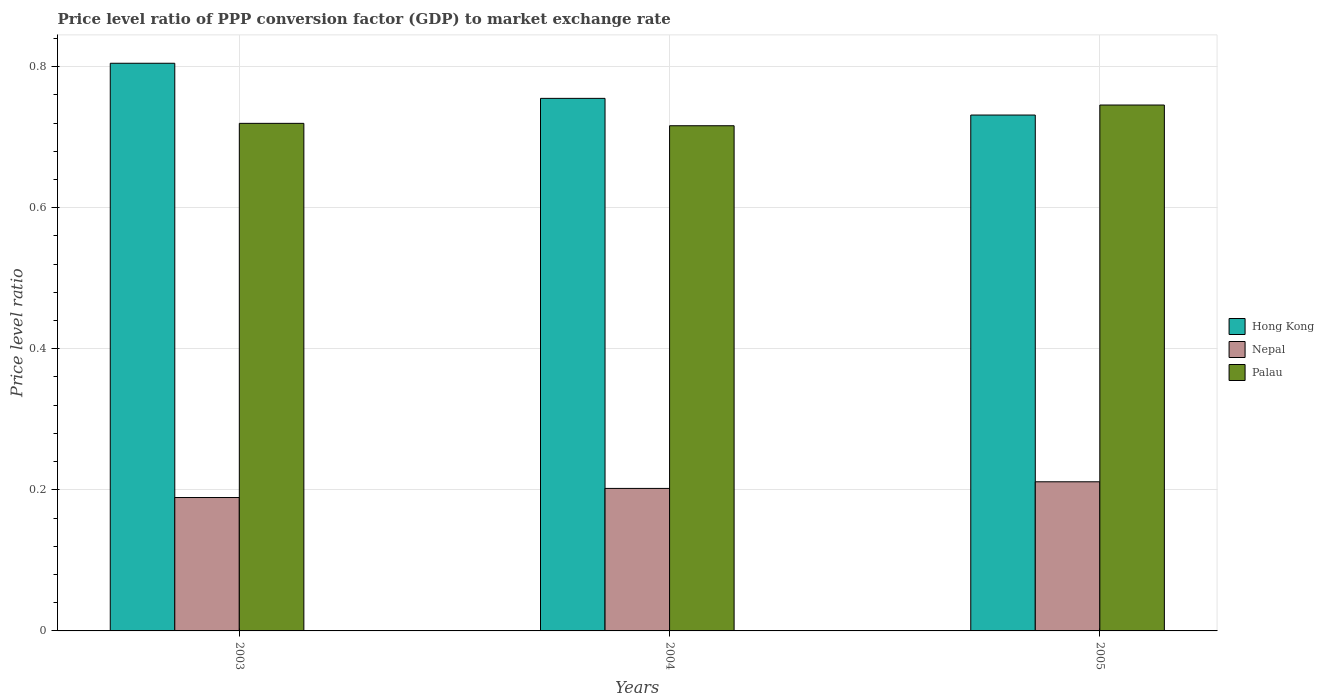How many different coloured bars are there?
Make the answer very short. 3. How many groups of bars are there?
Provide a succinct answer. 3. Are the number of bars per tick equal to the number of legend labels?
Your answer should be compact. Yes. How many bars are there on the 2nd tick from the left?
Ensure brevity in your answer.  3. What is the price level ratio in Hong Kong in 2004?
Offer a very short reply. 0.76. Across all years, what is the maximum price level ratio in Hong Kong?
Keep it short and to the point. 0.8. Across all years, what is the minimum price level ratio in Nepal?
Give a very brief answer. 0.19. In which year was the price level ratio in Nepal minimum?
Offer a terse response. 2003. What is the total price level ratio in Hong Kong in the graph?
Keep it short and to the point. 2.29. What is the difference between the price level ratio in Hong Kong in 2004 and that in 2005?
Offer a terse response. 0.02. What is the difference between the price level ratio in Palau in 2003 and the price level ratio in Nepal in 2004?
Offer a very short reply. 0.52. What is the average price level ratio in Nepal per year?
Provide a short and direct response. 0.2. In the year 2005, what is the difference between the price level ratio in Hong Kong and price level ratio in Nepal?
Provide a succinct answer. 0.52. In how many years, is the price level ratio in Nepal greater than 0.7600000000000001?
Your answer should be very brief. 0. What is the ratio of the price level ratio in Palau in 2003 to that in 2004?
Ensure brevity in your answer.  1. Is the price level ratio in Palau in 2003 less than that in 2004?
Your answer should be compact. No. Is the difference between the price level ratio in Hong Kong in 2003 and 2005 greater than the difference between the price level ratio in Nepal in 2003 and 2005?
Provide a short and direct response. Yes. What is the difference between the highest and the second highest price level ratio in Hong Kong?
Your answer should be compact. 0.05. What is the difference between the highest and the lowest price level ratio in Palau?
Your response must be concise. 0.03. In how many years, is the price level ratio in Palau greater than the average price level ratio in Palau taken over all years?
Provide a short and direct response. 1. What does the 2nd bar from the left in 2005 represents?
Your response must be concise. Nepal. What does the 2nd bar from the right in 2005 represents?
Make the answer very short. Nepal. Is it the case that in every year, the sum of the price level ratio in Palau and price level ratio in Hong Kong is greater than the price level ratio in Nepal?
Ensure brevity in your answer.  Yes. How many bars are there?
Your response must be concise. 9. What is the difference between two consecutive major ticks on the Y-axis?
Your answer should be compact. 0.2. Does the graph contain grids?
Make the answer very short. Yes. Where does the legend appear in the graph?
Keep it short and to the point. Center right. How many legend labels are there?
Your answer should be very brief. 3. What is the title of the graph?
Offer a terse response. Price level ratio of PPP conversion factor (GDP) to market exchange rate. What is the label or title of the Y-axis?
Offer a terse response. Price level ratio. What is the Price level ratio in Hong Kong in 2003?
Offer a terse response. 0.8. What is the Price level ratio of Nepal in 2003?
Ensure brevity in your answer.  0.19. What is the Price level ratio in Palau in 2003?
Ensure brevity in your answer.  0.72. What is the Price level ratio in Hong Kong in 2004?
Your answer should be very brief. 0.76. What is the Price level ratio of Nepal in 2004?
Your answer should be compact. 0.2. What is the Price level ratio of Palau in 2004?
Make the answer very short. 0.72. What is the Price level ratio in Hong Kong in 2005?
Ensure brevity in your answer.  0.73. What is the Price level ratio of Nepal in 2005?
Your response must be concise. 0.21. What is the Price level ratio of Palau in 2005?
Give a very brief answer. 0.75. Across all years, what is the maximum Price level ratio in Hong Kong?
Your answer should be compact. 0.8. Across all years, what is the maximum Price level ratio of Nepal?
Your answer should be very brief. 0.21. Across all years, what is the maximum Price level ratio of Palau?
Ensure brevity in your answer.  0.75. Across all years, what is the minimum Price level ratio of Hong Kong?
Your answer should be compact. 0.73. Across all years, what is the minimum Price level ratio in Nepal?
Provide a short and direct response. 0.19. Across all years, what is the minimum Price level ratio of Palau?
Your answer should be very brief. 0.72. What is the total Price level ratio of Hong Kong in the graph?
Keep it short and to the point. 2.29. What is the total Price level ratio in Nepal in the graph?
Offer a terse response. 0.6. What is the total Price level ratio in Palau in the graph?
Ensure brevity in your answer.  2.18. What is the difference between the Price level ratio of Hong Kong in 2003 and that in 2004?
Give a very brief answer. 0.05. What is the difference between the Price level ratio of Nepal in 2003 and that in 2004?
Your answer should be very brief. -0.01. What is the difference between the Price level ratio in Palau in 2003 and that in 2004?
Provide a short and direct response. 0. What is the difference between the Price level ratio in Hong Kong in 2003 and that in 2005?
Provide a succinct answer. 0.07. What is the difference between the Price level ratio of Nepal in 2003 and that in 2005?
Give a very brief answer. -0.02. What is the difference between the Price level ratio of Palau in 2003 and that in 2005?
Make the answer very short. -0.03. What is the difference between the Price level ratio in Hong Kong in 2004 and that in 2005?
Your answer should be compact. 0.02. What is the difference between the Price level ratio in Nepal in 2004 and that in 2005?
Your answer should be compact. -0.01. What is the difference between the Price level ratio in Palau in 2004 and that in 2005?
Provide a short and direct response. -0.03. What is the difference between the Price level ratio in Hong Kong in 2003 and the Price level ratio in Nepal in 2004?
Make the answer very short. 0.6. What is the difference between the Price level ratio in Hong Kong in 2003 and the Price level ratio in Palau in 2004?
Your answer should be very brief. 0.09. What is the difference between the Price level ratio of Nepal in 2003 and the Price level ratio of Palau in 2004?
Offer a very short reply. -0.53. What is the difference between the Price level ratio of Hong Kong in 2003 and the Price level ratio of Nepal in 2005?
Provide a succinct answer. 0.59. What is the difference between the Price level ratio of Hong Kong in 2003 and the Price level ratio of Palau in 2005?
Your response must be concise. 0.06. What is the difference between the Price level ratio in Nepal in 2003 and the Price level ratio in Palau in 2005?
Provide a short and direct response. -0.56. What is the difference between the Price level ratio of Hong Kong in 2004 and the Price level ratio of Nepal in 2005?
Keep it short and to the point. 0.54. What is the difference between the Price level ratio in Hong Kong in 2004 and the Price level ratio in Palau in 2005?
Your answer should be compact. 0.01. What is the difference between the Price level ratio in Nepal in 2004 and the Price level ratio in Palau in 2005?
Make the answer very short. -0.54. What is the average Price level ratio of Hong Kong per year?
Your answer should be very brief. 0.76. What is the average Price level ratio of Nepal per year?
Offer a very short reply. 0.2. What is the average Price level ratio in Palau per year?
Provide a succinct answer. 0.73. In the year 2003, what is the difference between the Price level ratio in Hong Kong and Price level ratio in Nepal?
Ensure brevity in your answer.  0.62. In the year 2003, what is the difference between the Price level ratio in Hong Kong and Price level ratio in Palau?
Keep it short and to the point. 0.09. In the year 2003, what is the difference between the Price level ratio in Nepal and Price level ratio in Palau?
Provide a succinct answer. -0.53. In the year 2004, what is the difference between the Price level ratio in Hong Kong and Price level ratio in Nepal?
Your response must be concise. 0.55. In the year 2004, what is the difference between the Price level ratio of Hong Kong and Price level ratio of Palau?
Give a very brief answer. 0.04. In the year 2004, what is the difference between the Price level ratio of Nepal and Price level ratio of Palau?
Ensure brevity in your answer.  -0.51. In the year 2005, what is the difference between the Price level ratio in Hong Kong and Price level ratio in Nepal?
Ensure brevity in your answer.  0.52. In the year 2005, what is the difference between the Price level ratio in Hong Kong and Price level ratio in Palau?
Ensure brevity in your answer.  -0.01. In the year 2005, what is the difference between the Price level ratio of Nepal and Price level ratio of Palau?
Offer a terse response. -0.53. What is the ratio of the Price level ratio of Hong Kong in 2003 to that in 2004?
Make the answer very short. 1.07. What is the ratio of the Price level ratio in Nepal in 2003 to that in 2004?
Provide a succinct answer. 0.94. What is the ratio of the Price level ratio in Palau in 2003 to that in 2004?
Your answer should be very brief. 1. What is the ratio of the Price level ratio in Hong Kong in 2003 to that in 2005?
Give a very brief answer. 1.1. What is the ratio of the Price level ratio of Nepal in 2003 to that in 2005?
Make the answer very short. 0.89. What is the ratio of the Price level ratio of Palau in 2003 to that in 2005?
Your answer should be compact. 0.97. What is the ratio of the Price level ratio of Hong Kong in 2004 to that in 2005?
Give a very brief answer. 1.03. What is the ratio of the Price level ratio of Nepal in 2004 to that in 2005?
Your answer should be very brief. 0.96. What is the ratio of the Price level ratio in Palau in 2004 to that in 2005?
Offer a terse response. 0.96. What is the difference between the highest and the second highest Price level ratio of Hong Kong?
Your answer should be very brief. 0.05. What is the difference between the highest and the second highest Price level ratio of Nepal?
Your response must be concise. 0.01. What is the difference between the highest and the second highest Price level ratio of Palau?
Offer a terse response. 0.03. What is the difference between the highest and the lowest Price level ratio in Hong Kong?
Give a very brief answer. 0.07. What is the difference between the highest and the lowest Price level ratio in Nepal?
Provide a succinct answer. 0.02. What is the difference between the highest and the lowest Price level ratio of Palau?
Offer a very short reply. 0.03. 